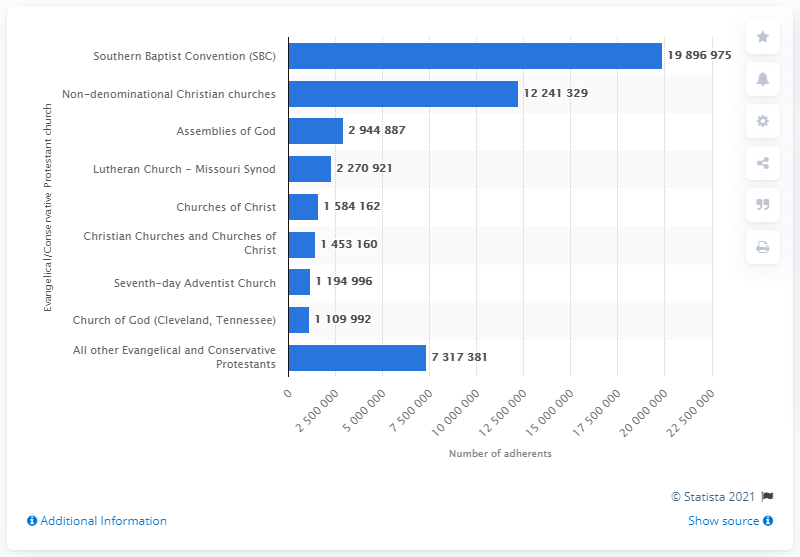Point out several critical features in this image. As of 2010, the Southern Baptist Convention had a total membership of 19,896,975. 